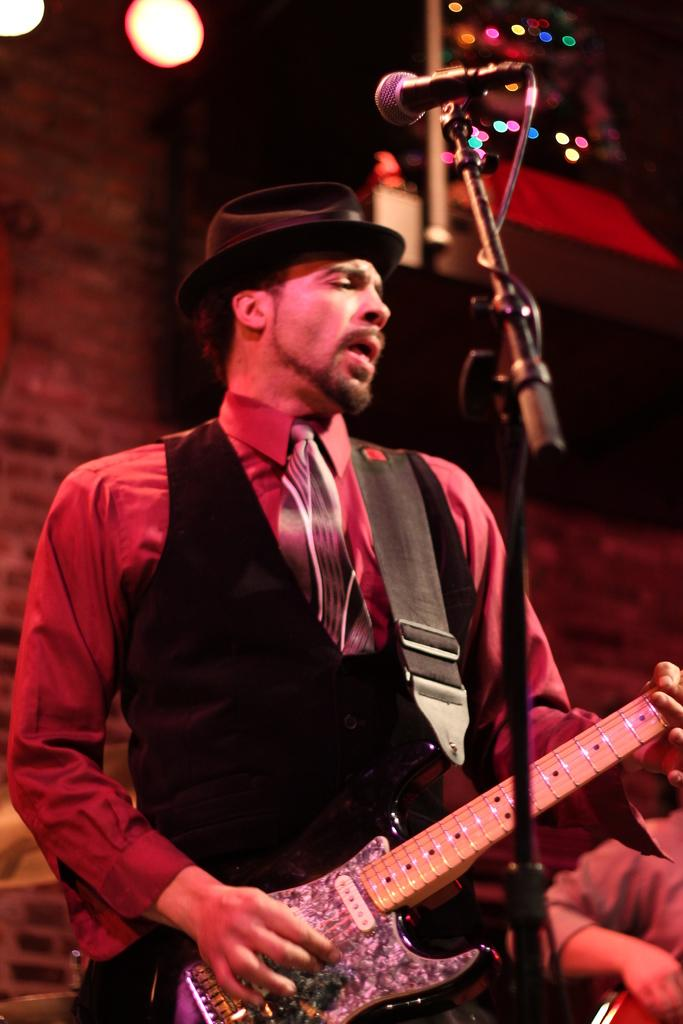What is the main subject of the image? The main subject of the image is a man. What is the man wearing on his upper body? The man is wearing a black jacket and a red shirt. What is the man doing in the image? The man is playing a guitar. What is the man wearing on his head? The man is wearing a black color cap on his head. What object is in front of the man? There is a microphone in front of the man. What type of creature can be seen interacting with the eggs in the image? There are no eggs or creatures present in the image; it features a man playing a guitar with a microphone in front of him. 